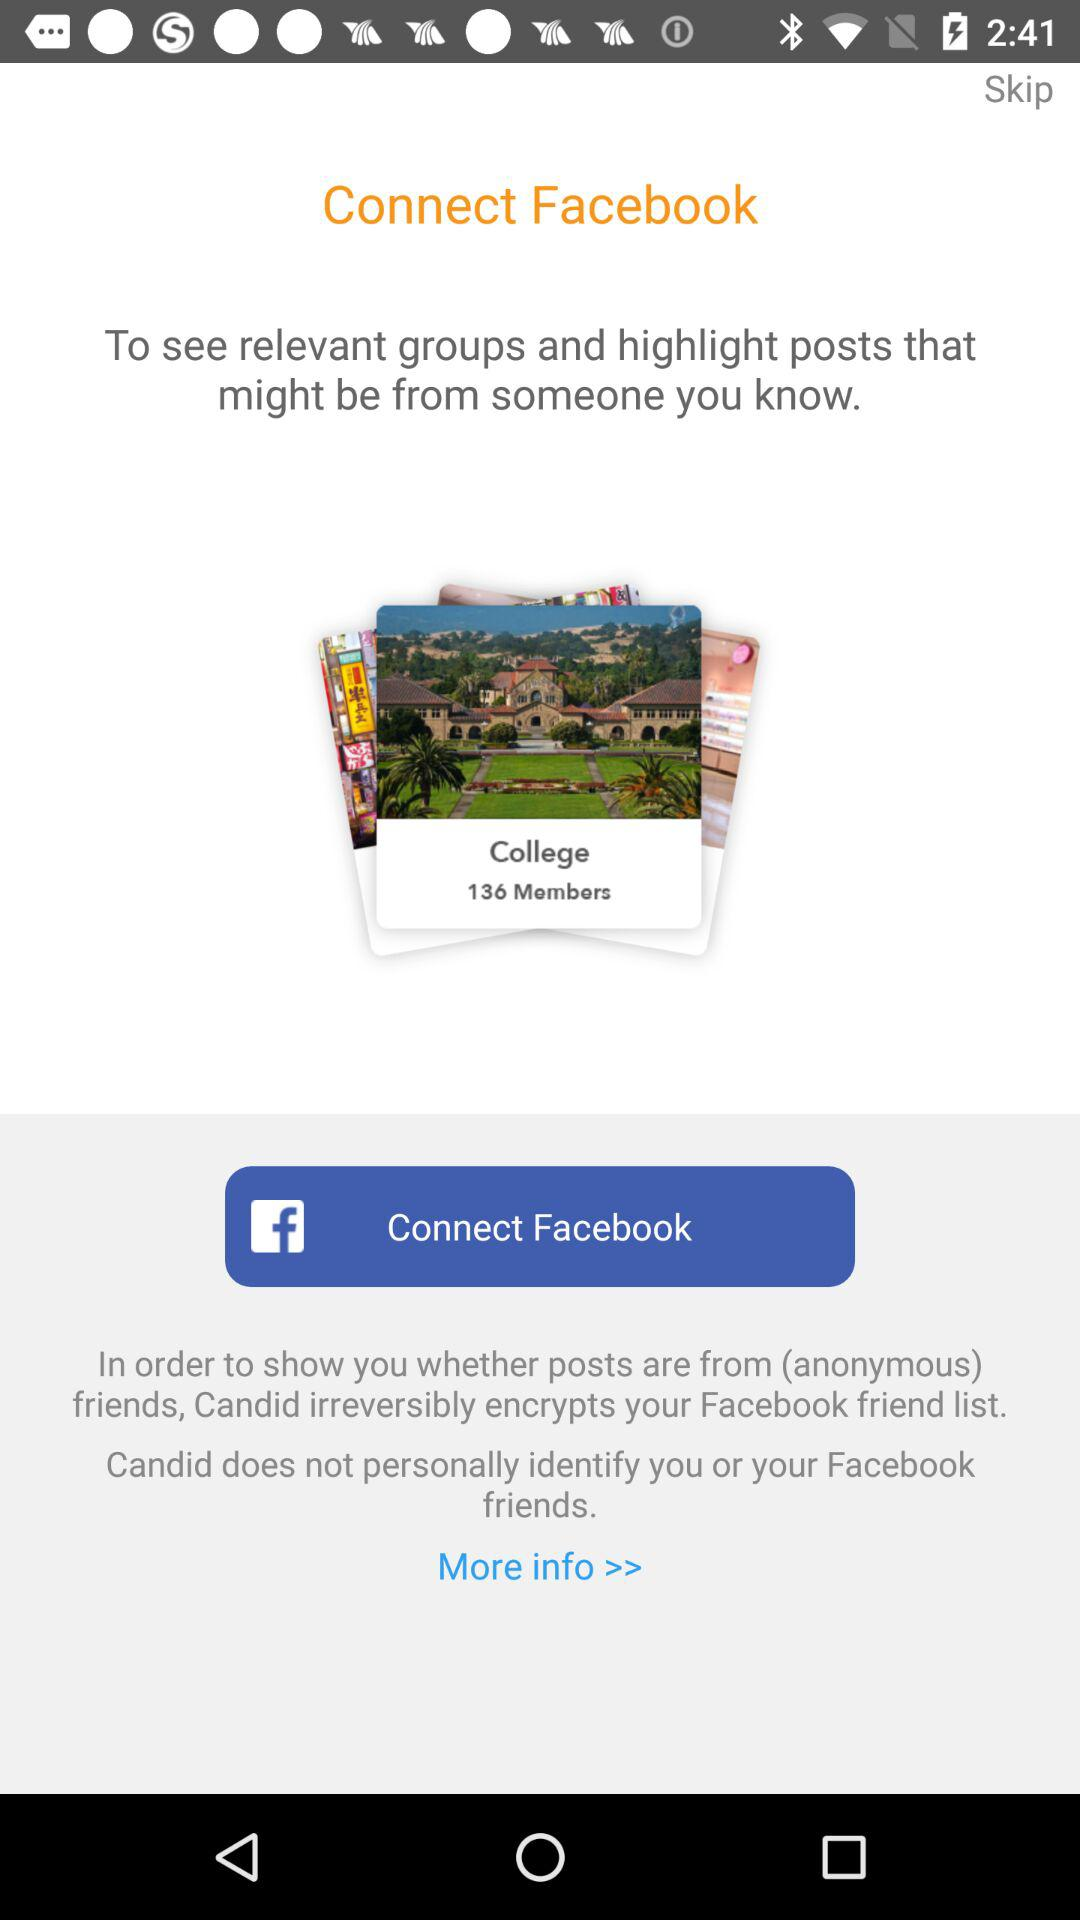What application is used to connect? The application that is used to connect is "Facebook". 